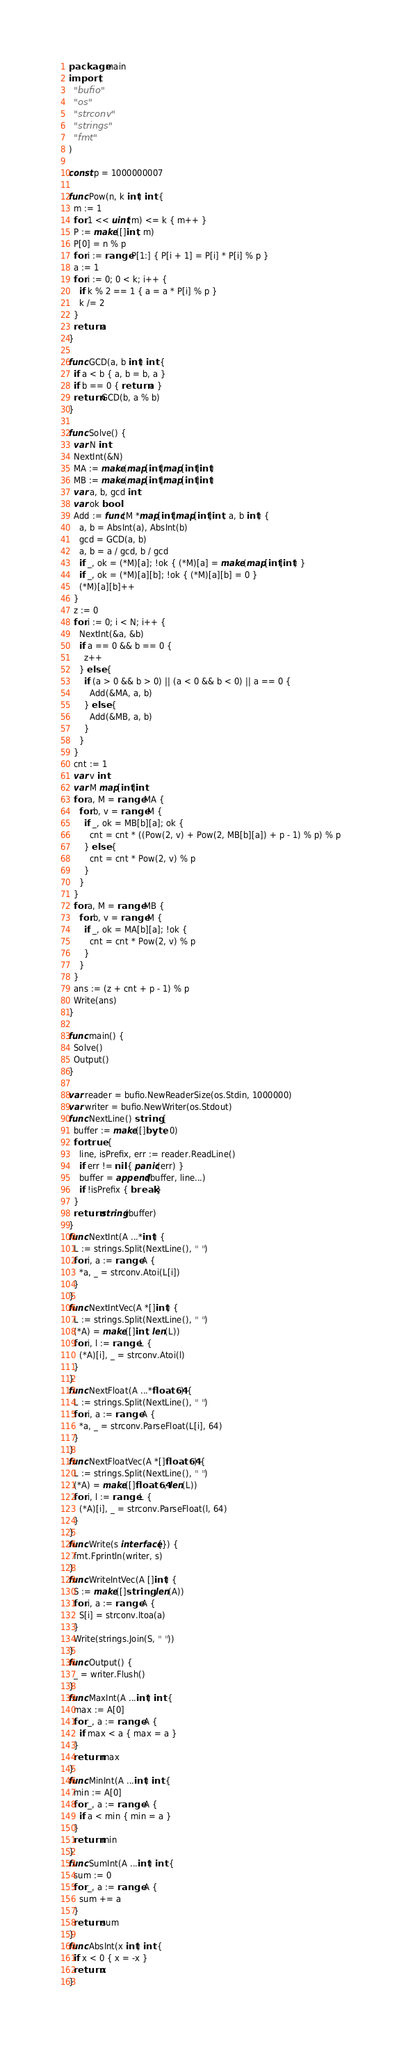<code> <loc_0><loc_0><loc_500><loc_500><_Go_>package main
import (
  "bufio"
  "os"
  "strconv"
  "strings"
  "fmt"
)

const p = 1000000007

func Pow(n, k int) int {
  m := 1
  for 1 << uint(m) <= k { m++ }
  P := make([]int, m)
  P[0] = n % p
  for i := range P[1:] { P[i + 1] = P[i] * P[i] % p }
  a := 1
  for i := 0; 0 < k; i++ {
    if k % 2 == 1 { a = a * P[i] % p }
    k /= 2
  }
  return a
}

func GCD(a, b int) int {
  if a < b { a, b = b, a }
  if b == 0 { return a }
  return GCD(b, a % b)
}

func Solve() {
  var N int
  NextInt(&N)
  MA := make(map[int]map[int]int)
  MB := make(map[int]map[int]int)
  var a, b, gcd int
  var ok bool
  Add := func(M *map[int]map[int]int, a, b int) {
    a, b = AbsInt(a), AbsInt(b)
    gcd = GCD(a, b)
    a, b = a / gcd, b / gcd
    if _, ok = (*M)[a]; !ok { (*M)[a] = make(map[int]int) }
    if _, ok = (*M)[a][b]; !ok { (*M)[a][b] = 0 }
    (*M)[a][b]++
  }
  z := 0
  for i := 0; i < N; i++ {
    NextInt(&a, &b)
    if a == 0 && b == 0 {
      z++
    } else {
      if (a > 0 && b > 0) || (a < 0 && b < 0) || a == 0 {
        Add(&MA, a, b)
      } else {
        Add(&MB, a, b)
      }
    }
  }
  cnt := 1
  var v int
  var M map[int]int
  for a, M = range MA {
    for b, v = range M {
      if _, ok = MB[b][a]; ok {
        cnt = cnt * ((Pow(2, v) + Pow(2, MB[b][a]) + p - 1) % p) % p
      } else {
        cnt = cnt * Pow(2, v) % p
      }
    }
  }
  for a, M = range MB {
    for b, v = range M {
      if _, ok = MA[b][a]; !ok {
        cnt = cnt * Pow(2, v) % p
      }
    }
  }
  ans := (z + cnt + p - 1) % p
  Write(ans)
}

func main() {
  Solve()
  Output()
}

var reader = bufio.NewReaderSize(os.Stdin, 1000000)
var writer = bufio.NewWriter(os.Stdout)
func NextLine() string {
  buffer := make([]byte, 0)
  for true {
    line, isPrefix, err := reader.ReadLine()
    if err != nil { panic(err) }
    buffer = append(buffer, line...)
    if !isPrefix { break }
  }
  return string(buffer)
}
func NextInt(A ...*int) {
  L := strings.Split(NextLine(), " ")
  for i, a := range A {
    *a, _ = strconv.Atoi(L[i])
  }
}
func NextIntVec(A *[]int) {
  L := strings.Split(NextLine(), " ")
  (*A) = make([]int, len(L))
  for i, l := range L {
    (*A)[i], _ = strconv.Atoi(l)
  }
}
func NextFloat(A ...*float64) {
  L := strings.Split(NextLine(), " ")
  for i, a := range A {
    *a, _ = strconv.ParseFloat(L[i], 64)
  }
}
func NextFloatVec(A *[]float64) {
  L := strings.Split(NextLine(), " ")
  (*A) = make([]float64, len(L))
  for i, l := range L {
    (*A)[i], _ = strconv.ParseFloat(l, 64)
  }
}
func Write(s interface{}) {
  fmt.Fprintln(writer, s)
}
func WriteIntVec(A []int) {
  S := make([]string, len(A))
  for i, a := range A {
    S[i] = strconv.Itoa(a)
  }
  Write(strings.Join(S, " "))
}
func Output() {
  _ = writer.Flush()
}
func MaxInt(A ...int) int {
  max := A[0]
  for _, a := range A {
    if max < a { max = a }
  }
  return max
}
func MinInt(A ...int) int {
  min := A[0]
  for _, a := range A {
    if a < min { min = a }
  }
  return min
}
func SumInt(A ...int) int {
  sum := 0
  for _, a := range A {
    sum += a
  }
  return sum
}
func AbsInt(x int) int {
  if x < 0 { x = -x }
  return x
}</code> 